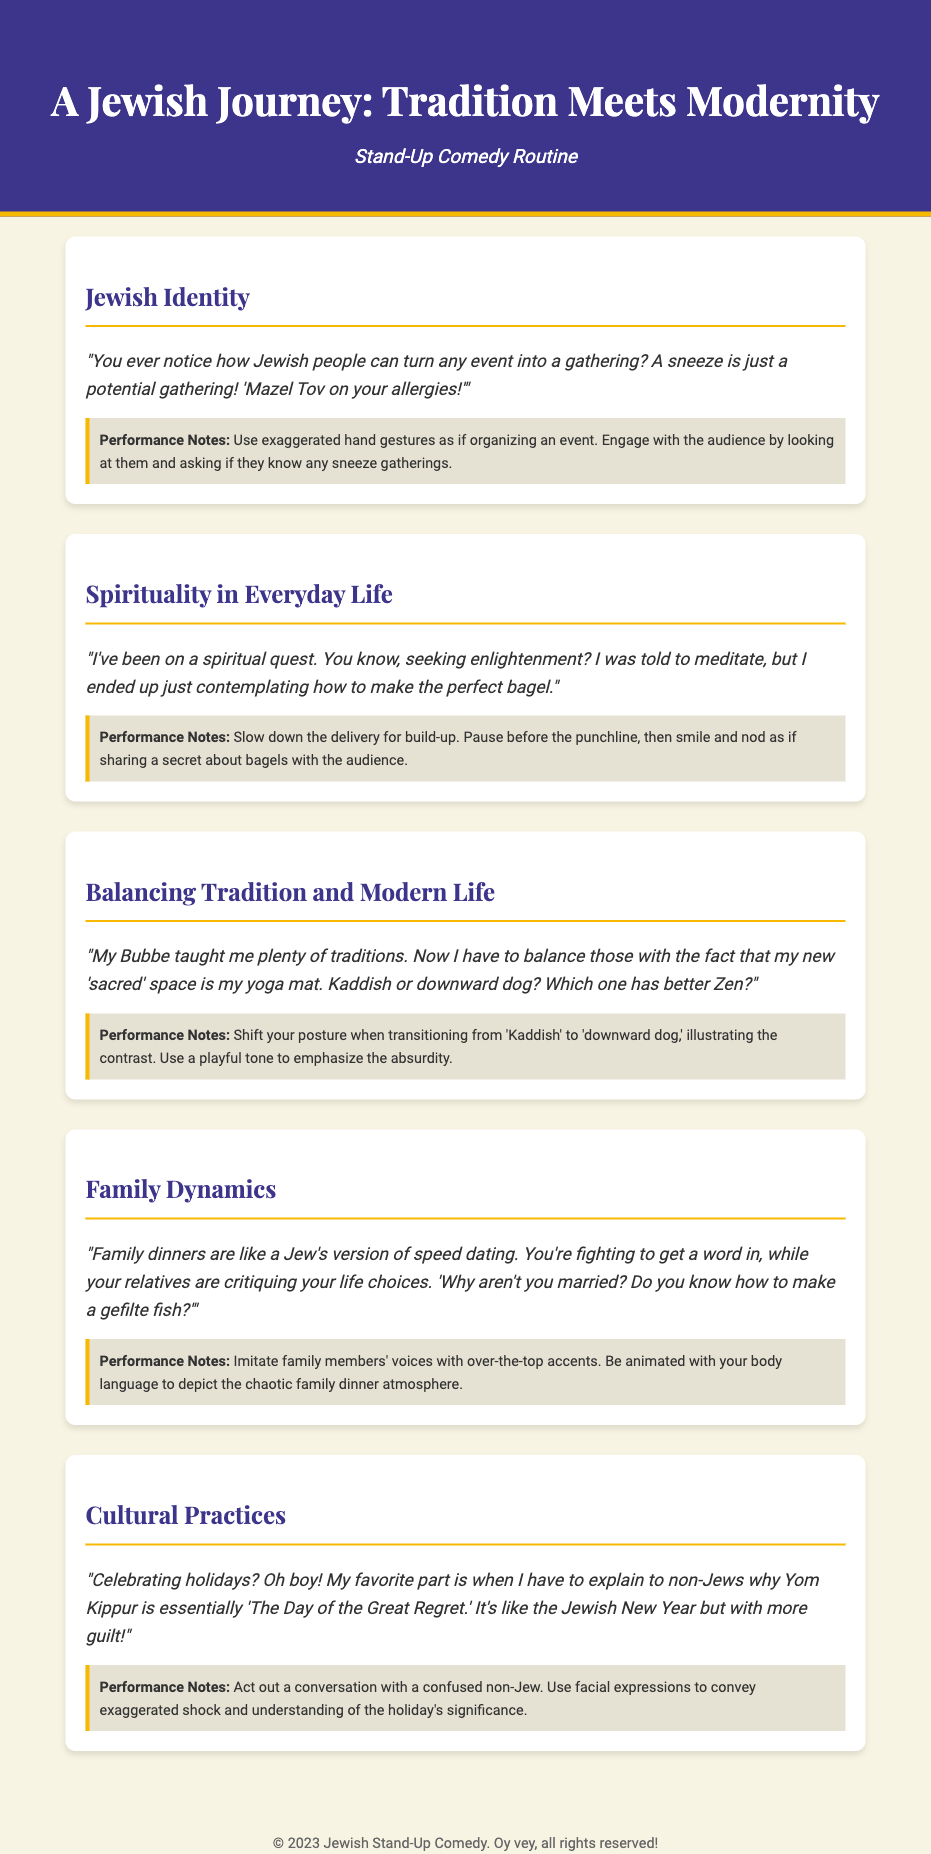What is the title of the document? The title is found in the header section at the top of the document.
Answer: A Jewish Journey: Tradition Meets Modernity How many sections are there in the document? The number of sections can be counted from the different headings present in the document.
Answer: Five What joke is related to spirituality? The specific joke can be identified under the section focusing on spirituality in everyday life.
Answer: "I've been on a spiritual quest..." What is the performance note for the Jewish Identity joke? The performance notes are provided directly after each joke in the document.
Answer: Use exaggerated hand gestures as if organizing an event Which holiday is described as "The Day of the Great Regret"? This description can be found in the Cultural Practices section of the document.
Answer: Yom Kippur What analogy is used to describe family dinners? The analogy can be found in the Family Dynamics section of the document.
Answer: A Jew's version of speed dating What unique element does the document bring together? The combination of different themes can be found by analyzing the sections of this document.
Answer: Tradition and Modernity What is the font used for the section headings? The document specifies the font in the style section for section headings.
Answer: Playfair Display 